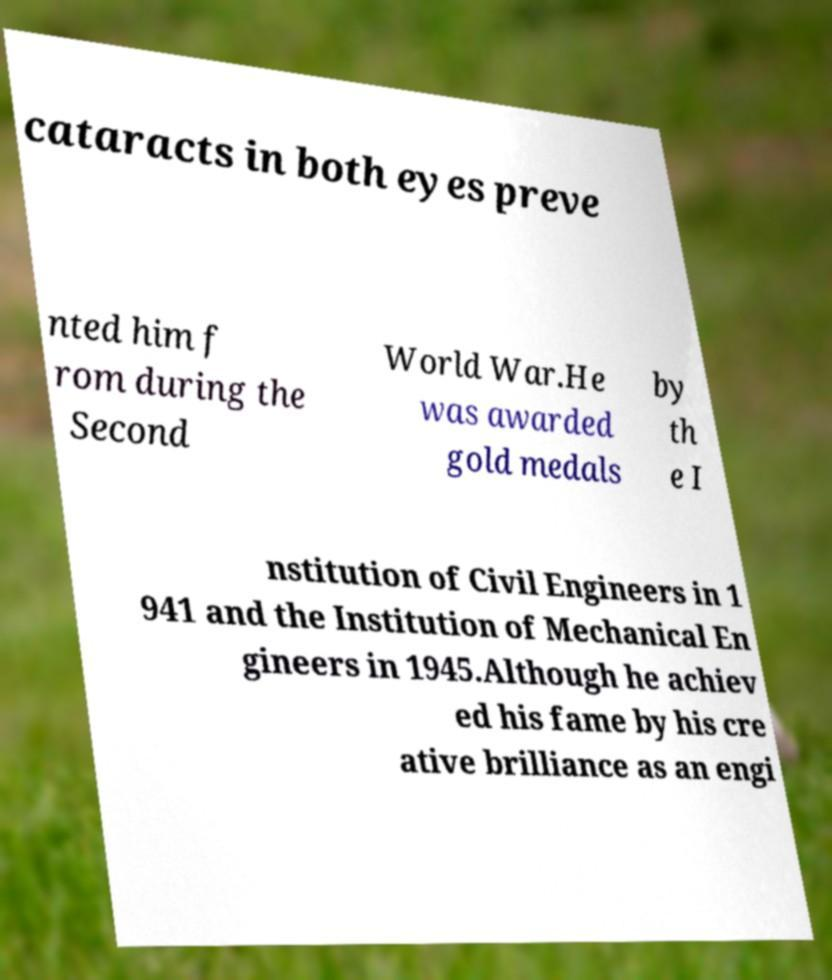Can you read and provide the text displayed in the image?This photo seems to have some interesting text. Can you extract and type it out for me? cataracts in both eyes preve nted him f rom during the Second World War.He was awarded gold medals by th e I nstitution of Civil Engineers in 1 941 and the Institution of Mechanical En gineers in 1945.Although he achiev ed his fame by his cre ative brilliance as an engi 